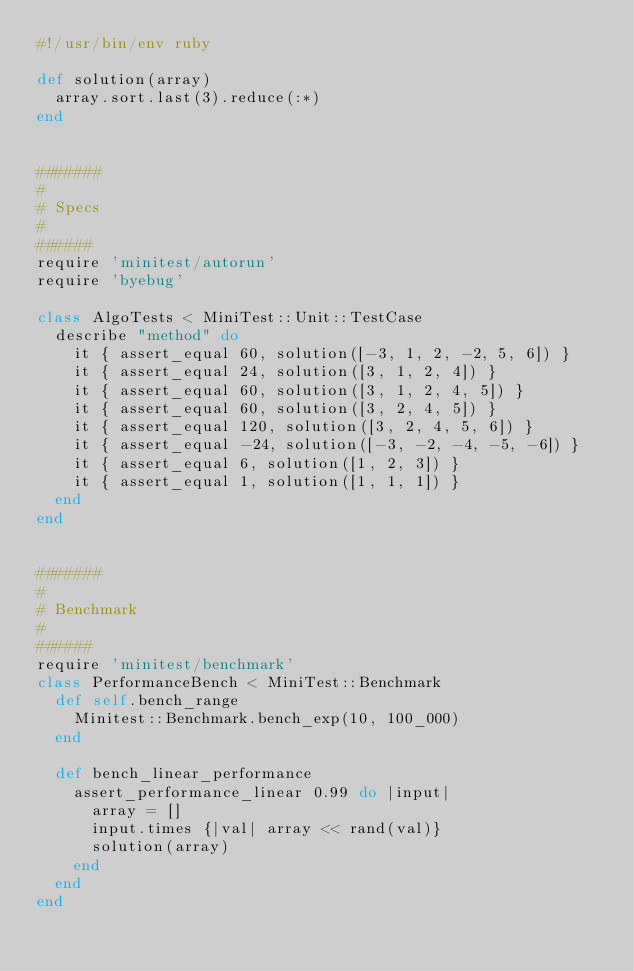<code> <loc_0><loc_0><loc_500><loc_500><_Ruby_>#!/usr/bin/env ruby

def solution(array)
  array.sort.last(3).reduce(:*)
end


#######
#
# Specs
#
######
require 'minitest/autorun'
require 'byebug'

class AlgoTests < MiniTest::Unit::TestCase
  describe "method" do
    it { assert_equal 60, solution([-3, 1, 2, -2, 5, 6]) }
    it { assert_equal 24, solution([3, 1, 2, 4]) }
    it { assert_equal 60, solution([3, 1, 2, 4, 5]) }
    it { assert_equal 60, solution([3, 2, 4, 5]) }
    it { assert_equal 120, solution([3, 2, 4, 5, 6]) }
    it { assert_equal -24, solution([-3, -2, -4, -5, -6]) }
    it { assert_equal 6, solution([1, 2, 3]) }
    it { assert_equal 1, solution([1, 1, 1]) }
  end
end


#######
#
# Benchmark
#
######
require 'minitest/benchmark'
class PerformanceBench < MiniTest::Benchmark    
  def self.bench_range 
    Minitest::Benchmark.bench_exp(10, 100_000)
  end
 
  def bench_linear_performance
    assert_performance_linear 0.99 do |input|
      array = []
      input.times {|val| array << rand(val)}
      solution(array)
    end
  end
end
</code> 